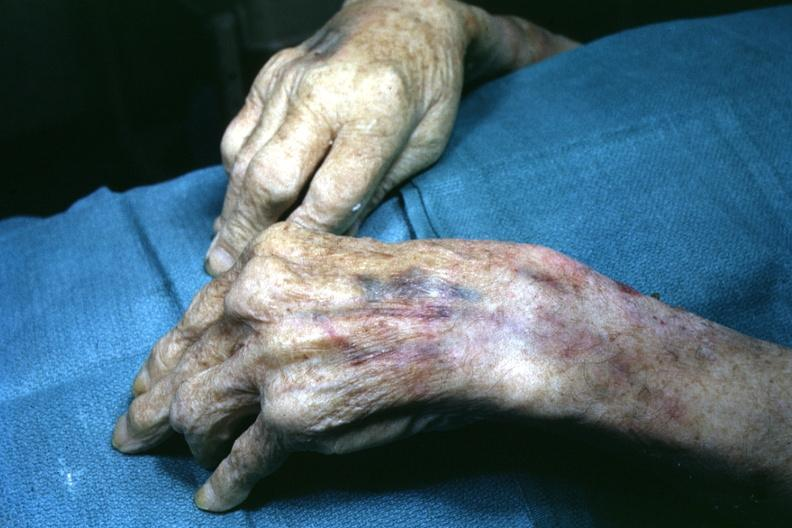what is present?
Answer the question using a single word or phrase. Gout 